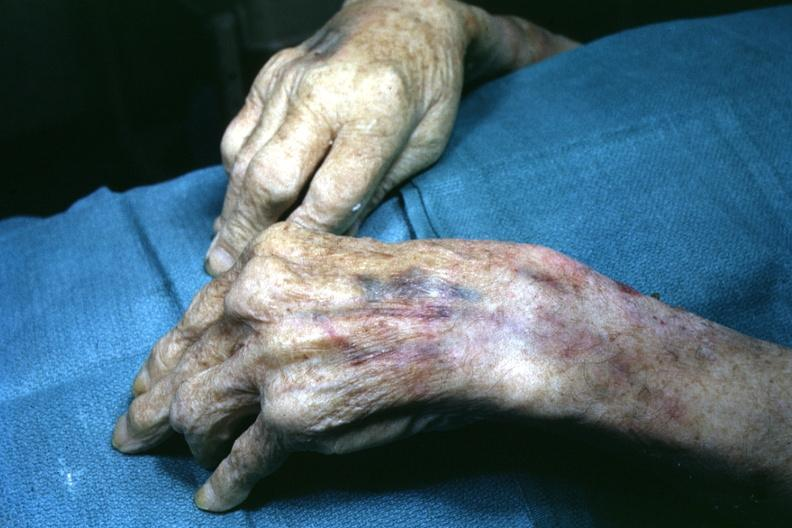what is present?
Answer the question using a single word or phrase. Gout 